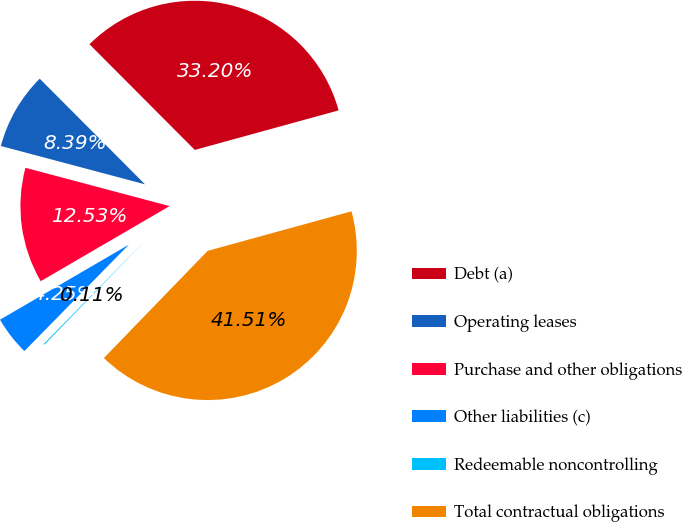<chart> <loc_0><loc_0><loc_500><loc_500><pie_chart><fcel>Debt (a)<fcel>Operating leases<fcel>Purchase and other obligations<fcel>Other liabilities (c)<fcel>Redeemable noncontrolling<fcel>Total contractual obligations<nl><fcel>33.2%<fcel>8.39%<fcel>12.53%<fcel>4.25%<fcel>0.11%<fcel>41.51%<nl></chart> 